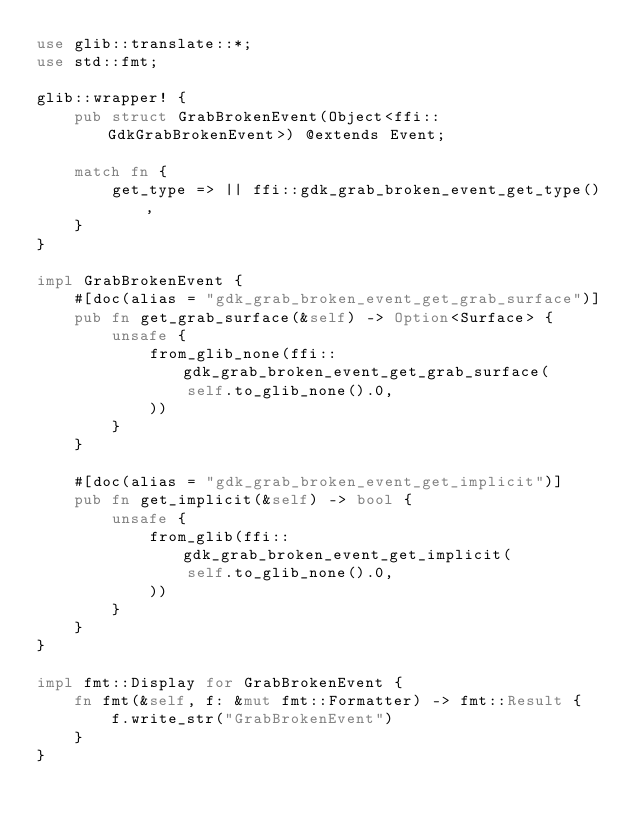<code> <loc_0><loc_0><loc_500><loc_500><_Rust_>use glib::translate::*;
use std::fmt;

glib::wrapper! {
    pub struct GrabBrokenEvent(Object<ffi::GdkGrabBrokenEvent>) @extends Event;

    match fn {
        get_type => || ffi::gdk_grab_broken_event_get_type(),
    }
}

impl GrabBrokenEvent {
    #[doc(alias = "gdk_grab_broken_event_get_grab_surface")]
    pub fn get_grab_surface(&self) -> Option<Surface> {
        unsafe {
            from_glib_none(ffi::gdk_grab_broken_event_get_grab_surface(
                self.to_glib_none().0,
            ))
        }
    }

    #[doc(alias = "gdk_grab_broken_event_get_implicit")]
    pub fn get_implicit(&self) -> bool {
        unsafe {
            from_glib(ffi::gdk_grab_broken_event_get_implicit(
                self.to_glib_none().0,
            ))
        }
    }
}

impl fmt::Display for GrabBrokenEvent {
    fn fmt(&self, f: &mut fmt::Formatter) -> fmt::Result {
        f.write_str("GrabBrokenEvent")
    }
}
</code> 